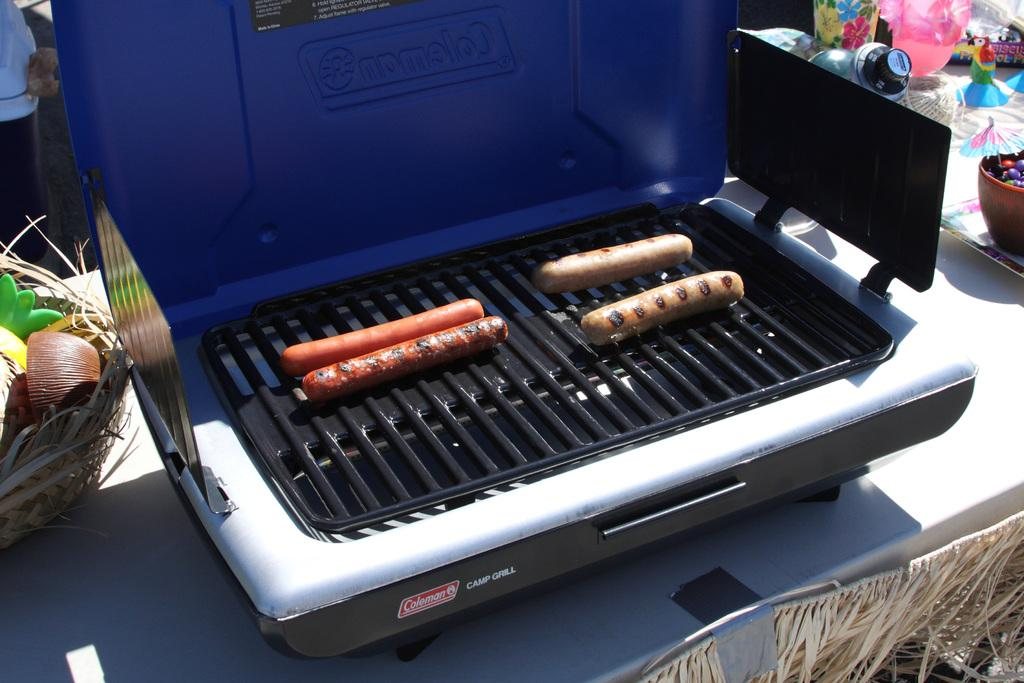Provide a one-sentence caption for the provided image. Hot dogs cooking on a Coleman Camp Grill. 